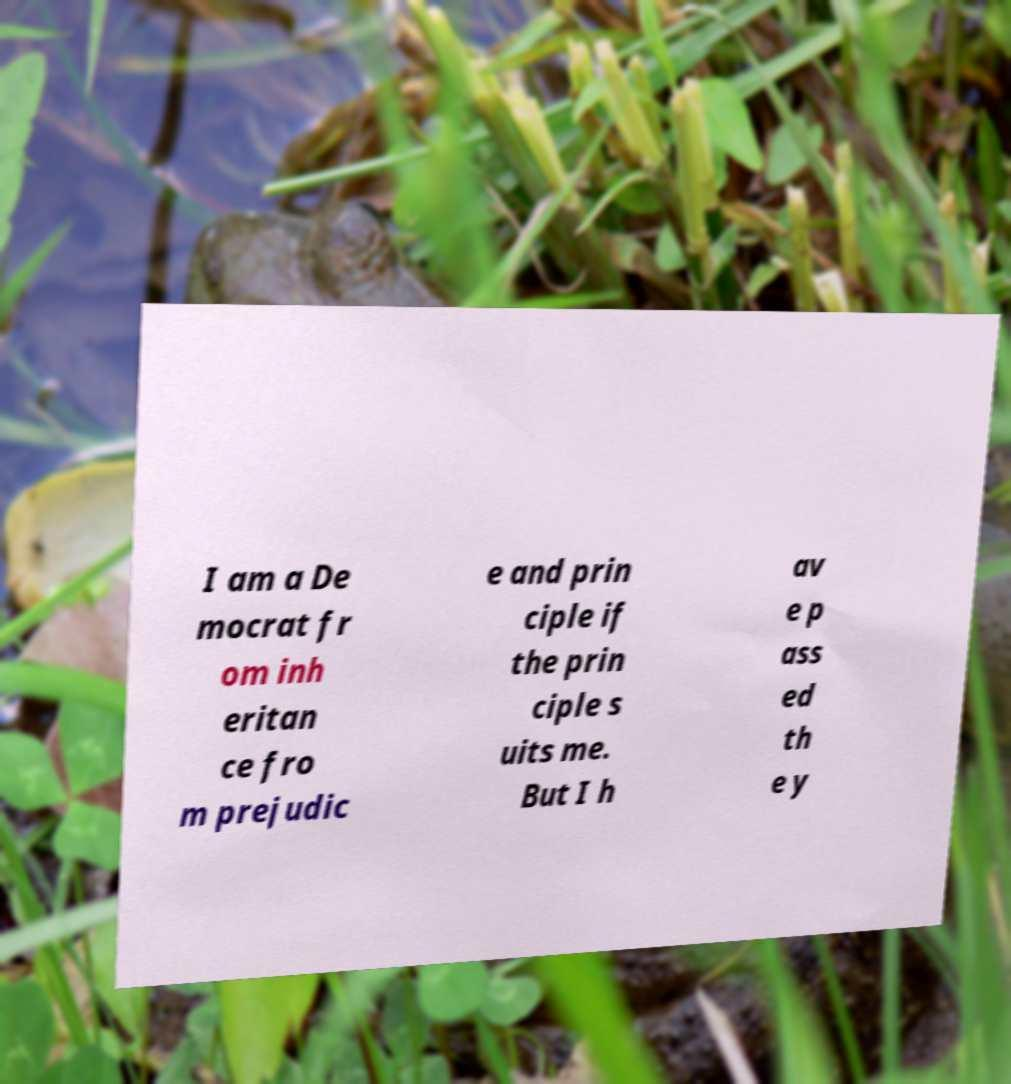Please identify and transcribe the text found in this image. I am a De mocrat fr om inh eritan ce fro m prejudic e and prin ciple if the prin ciple s uits me. But I h av e p ass ed th e y 